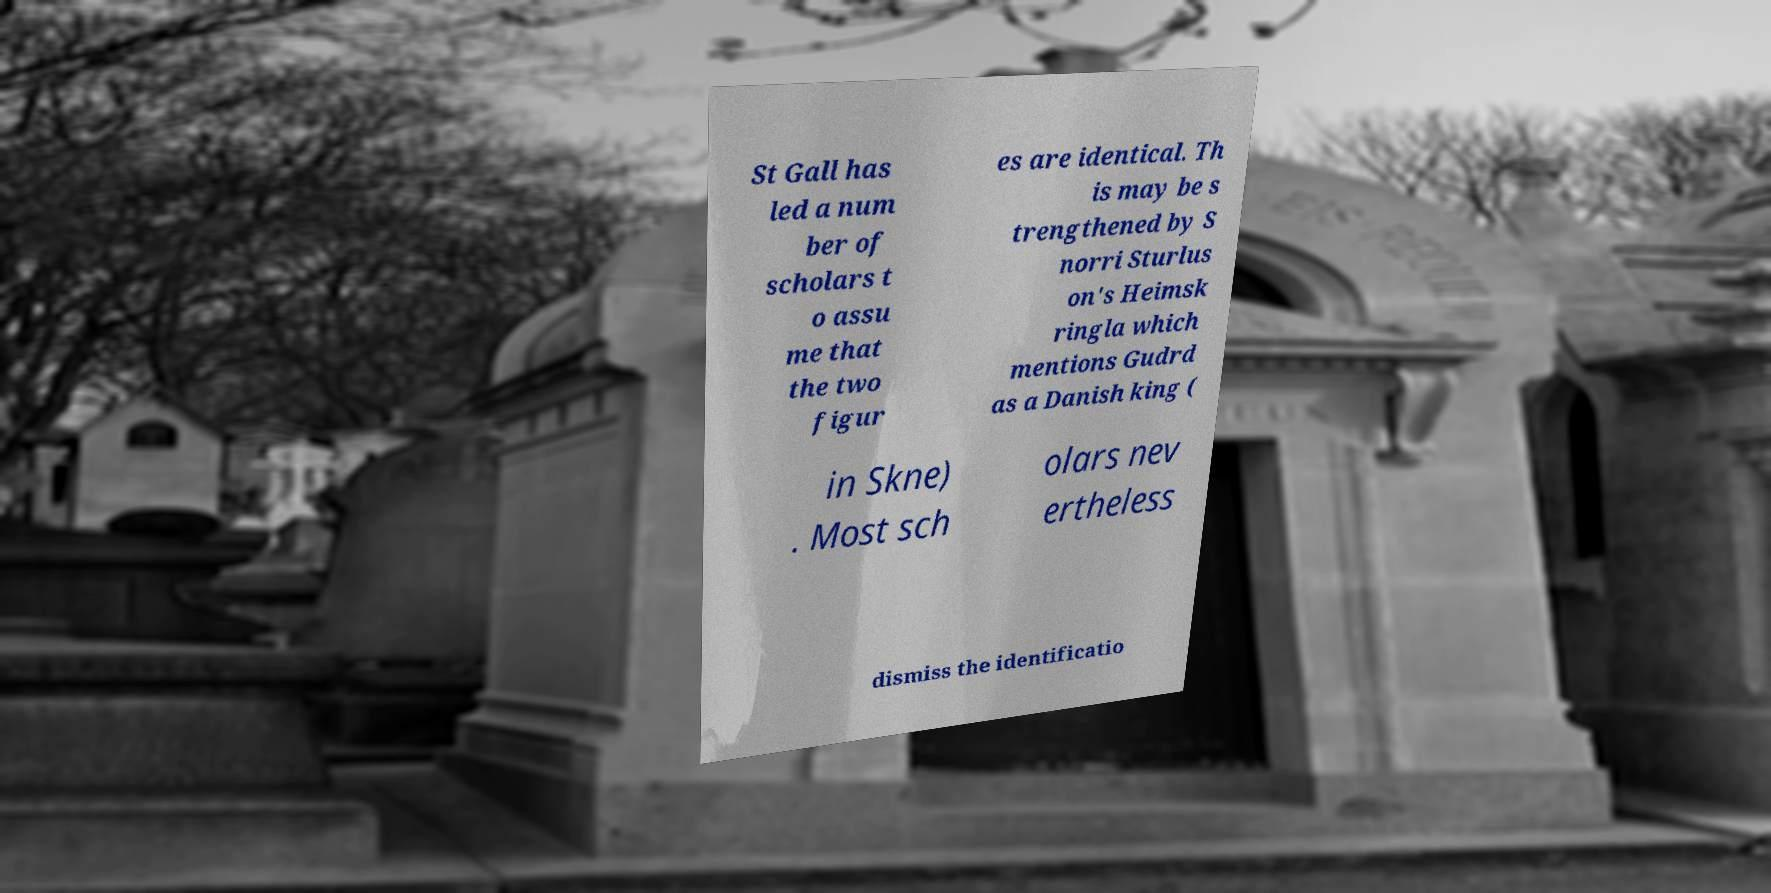Could you extract and type out the text from this image? St Gall has led a num ber of scholars t o assu me that the two figur es are identical. Th is may be s trengthened by S norri Sturlus on's Heimsk ringla which mentions Gudrd as a Danish king ( in Skne) . Most sch olars nev ertheless dismiss the identificatio 